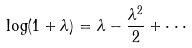<formula> <loc_0><loc_0><loc_500><loc_500>\log ( 1 + \lambda ) = \lambda - \frac { \lambda ^ { 2 } } { 2 } + \cdot \cdot \cdot</formula> 